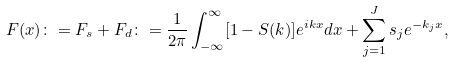<formula> <loc_0><loc_0><loc_500><loc_500>F ( x ) \colon = F _ { s } + F _ { d } \colon = \frac { 1 } { 2 \pi } \int _ { - \infty } ^ { \infty } [ 1 - S ( k ) ] e ^ { i k x } d x + \sum _ { j = 1 } ^ { J } s _ { j } e ^ { - k _ { j } x } ,</formula> 